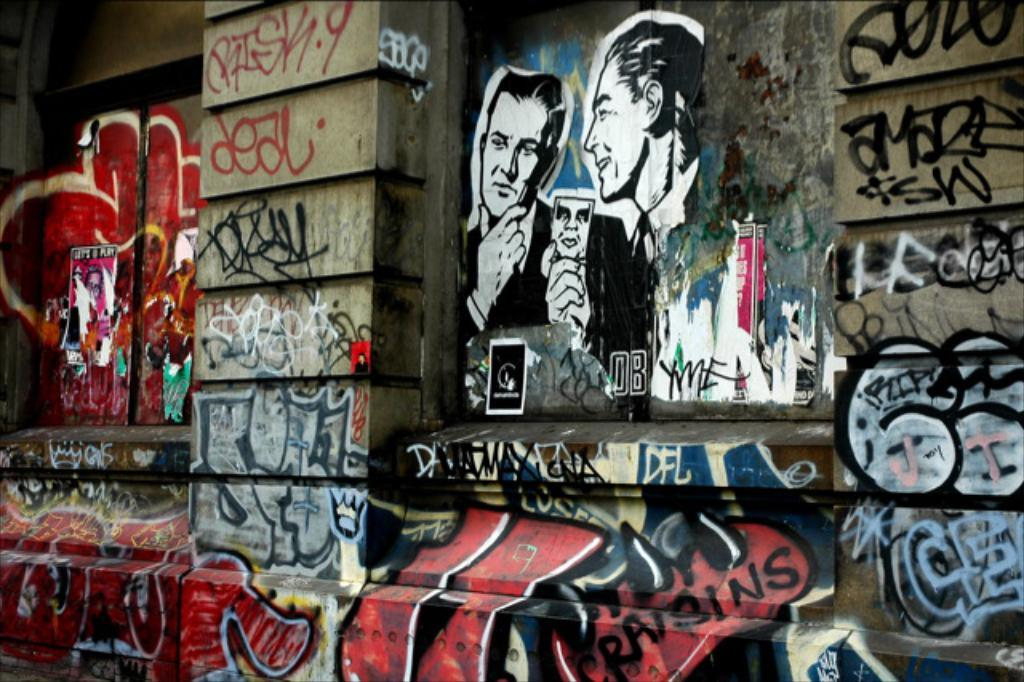What is depicted on the wall in the image? There is graffiti on a wall in the image. What type of curtain can be seen hanging from the boat in the image? There is no boat or curtain present in the image; it only features graffiti on a wall. 